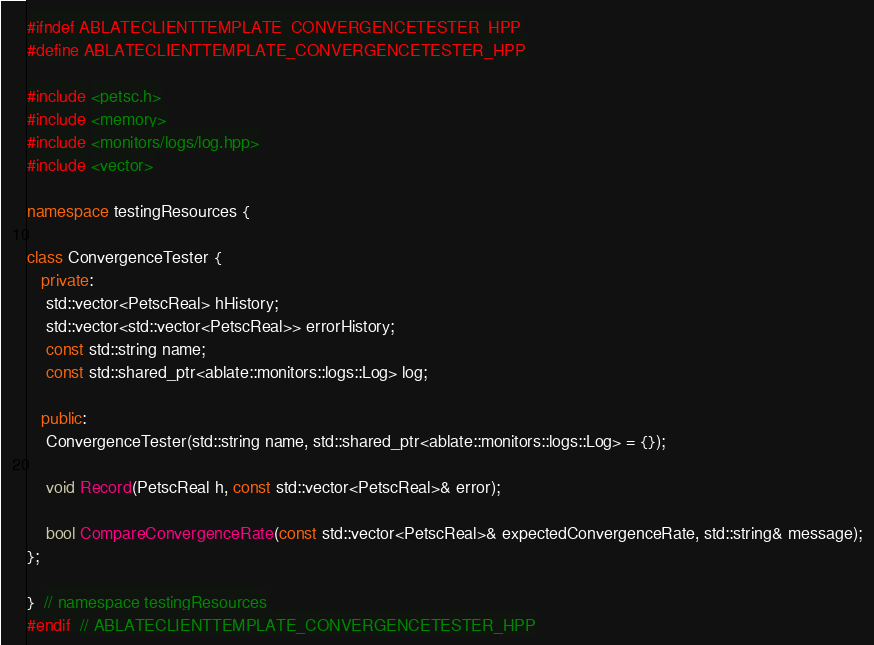<code> <loc_0><loc_0><loc_500><loc_500><_C++_>#ifndef ABLATECLIENTTEMPLATE_CONVERGENCETESTER_HPP
#define ABLATECLIENTTEMPLATE_CONVERGENCETESTER_HPP

#include <petsc.h>
#include <memory>
#include <monitors/logs/log.hpp>
#include <vector>

namespace testingResources {

class ConvergenceTester {
   private:
    std::vector<PetscReal> hHistory;
    std::vector<std::vector<PetscReal>> errorHistory;
    const std::string name;
    const std::shared_ptr<ablate::monitors::logs::Log> log;

   public:
    ConvergenceTester(std::string name, std::shared_ptr<ablate::monitors::logs::Log> = {});

    void Record(PetscReal h, const std::vector<PetscReal>& error);

    bool CompareConvergenceRate(const std::vector<PetscReal>& expectedConvergenceRate, std::string& message);
};

}  // namespace testingResources
#endif  // ABLATECLIENTTEMPLATE_CONVERGENCETESTER_HPP
</code> 